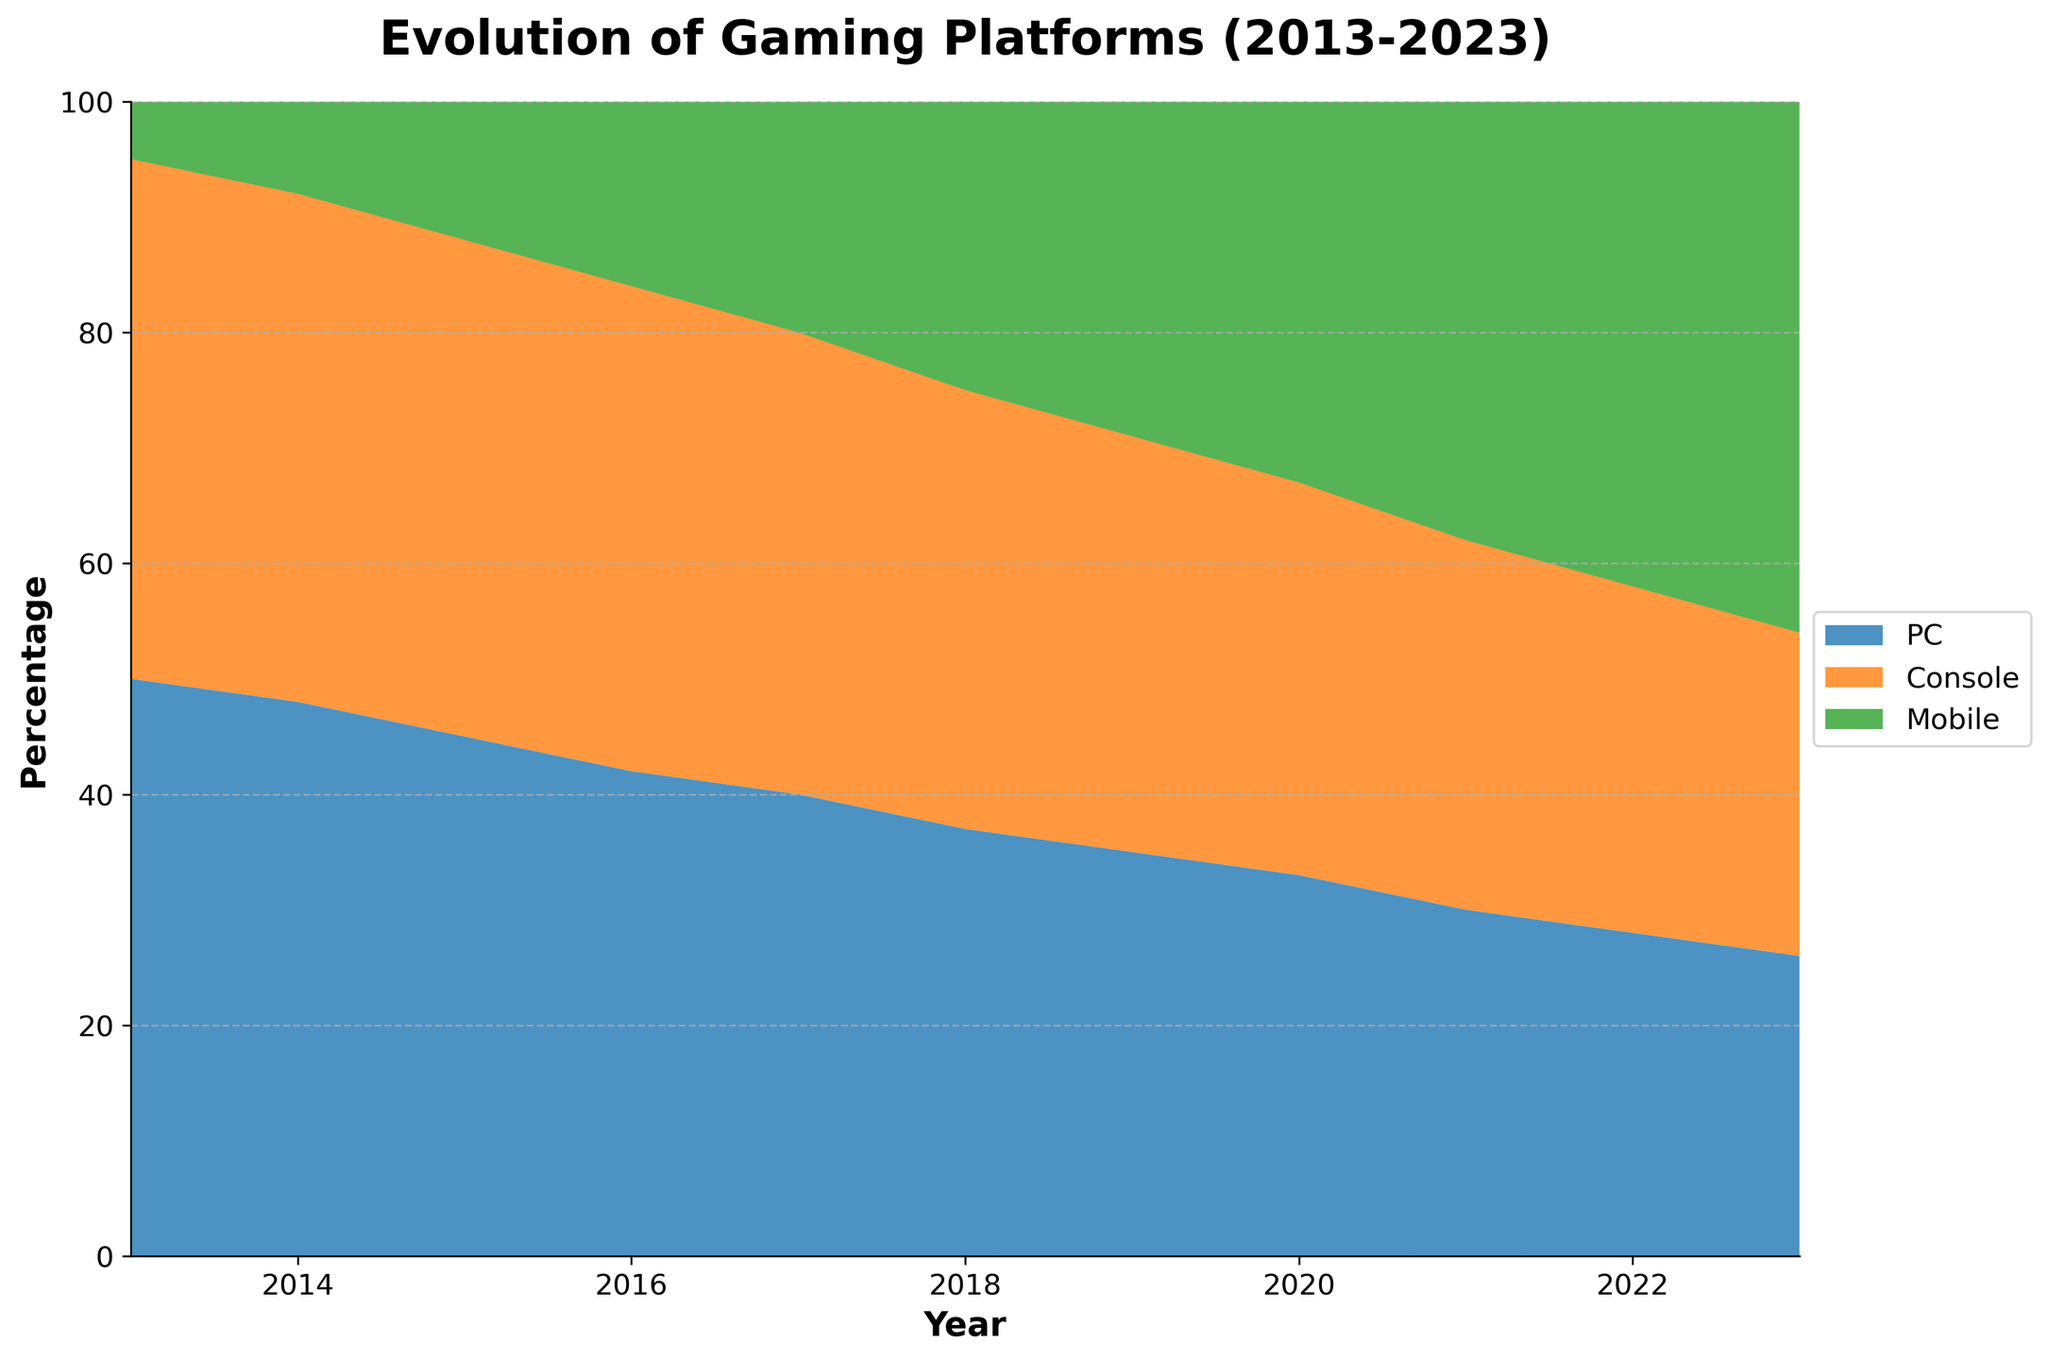what is the overall trend for PC usage from 2013 to 2023? From the figure, we can see that the area corresponding to PC usage shrinks over the years. Initially, PC usage was around 50% in 2013 and it decreases consistently until it reaches around 26% in 2023.
Answer: It decreases Which device saw the greatest increase in usage over the decade? Looking at the figure, we notice that the area for mobile usage expands the most compared to PC and Console. Mobile usage starts at 5% in 2013 and grows to 46% in 2023.
Answer: Mobile In which year did Mobile usage equal Console usage? By observing the points where the areas for Mobile and Console intersect, we find that the two usages are equal around the year 2020.
Answer: 2020 By how much did Console usage change from 2013 to 2023? In 2013, Console usage was about 45%. By 2023, it decreased to approximately 28%. The change can be calculated as 45% - 28% = 17%.
Answer: Decreased by 17% When did Mobile usage surpass PC usage? By looking at the overlapping areas, we see that Mobile usage surpasses PC usage between 2020 and 2021.
Answer: Between 2020 and 2021 What are the respective percentages of PC, Console, and Mobile usage in 2023? From the figure, the annotations at the end of the year 2023 give the exact percentages: PC is at 26%, Console is at 28%, and Mobile is at 46%.
Answer: PC: 26%, Console: 28%, Mobile: 46% How did the PC and Console usage percentages compare in 2017? The figure shows that in 2017, both PC and Console usage were equal at 40%.
Answer: They were equal Which device had the smallest usage percentage in 2018? Observing the figure, it's clear that Mobile had the smallest usage percentage, which was about 25% in 2018.
Answer: Mobile What can you infer about the popularity of gaming platforms over the decade? From the figure, it is evident that Mobile usage has significantly grown, surpassing both PC and Console usage towards the end of the decade. Console usage sees a slight gradual decline, and PC usage shows a consistent decrease.
Answer: Mobile popularity increased, while PC and Console usage decreased 